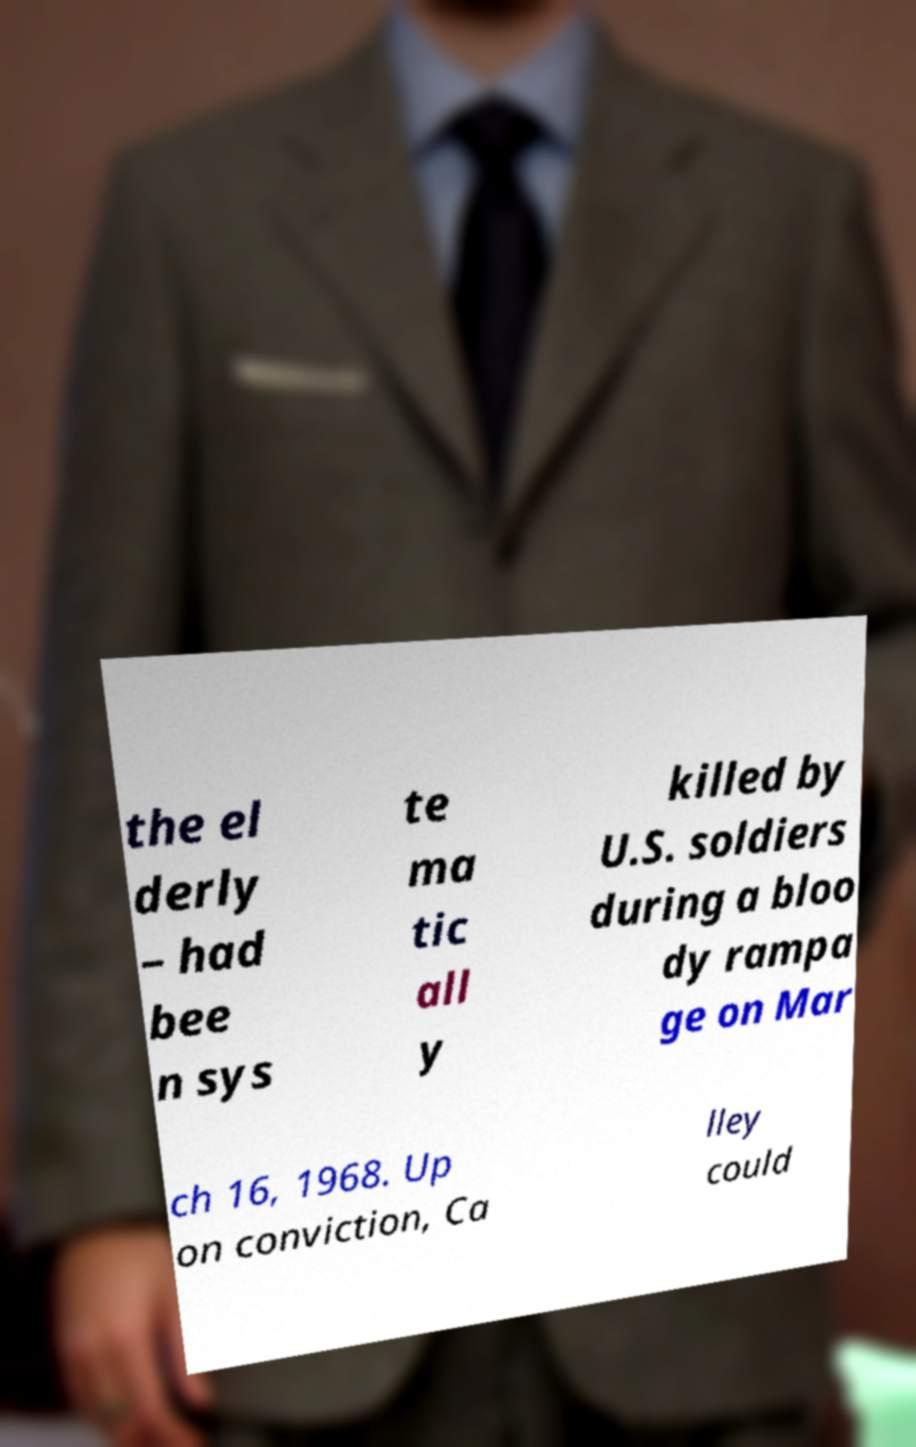Please read and relay the text visible in this image. What does it say? the el derly – had bee n sys te ma tic all y killed by U.S. soldiers during a bloo dy rampa ge on Mar ch 16, 1968. Up on conviction, Ca lley could 